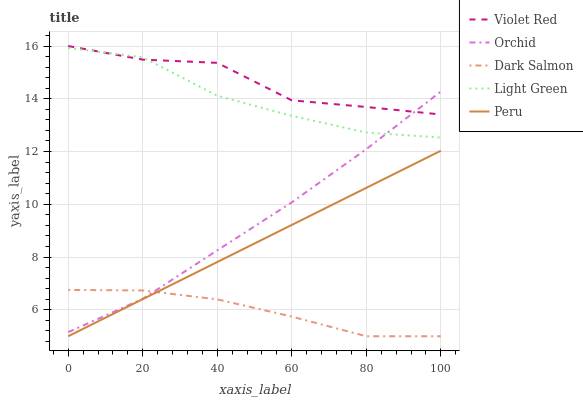Does Dark Salmon have the minimum area under the curve?
Answer yes or no. Yes. Does Violet Red have the maximum area under the curve?
Answer yes or no. Yes. Does Violet Red have the minimum area under the curve?
Answer yes or no. No. Does Dark Salmon have the maximum area under the curve?
Answer yes or no. No. Is Peru the smoothest?
Answer yes or no. Yes. Is Violet Red the roughest?
Answer yes or no. Yes. Is Dark Salmon the smoothest?
Answer yes or no. No. Is Dark Salmon the roughest?
Answer yes or no. No. Does Peru have the lowest value?
Answer yes or no. Yes. Does Violet Red have the lowest value?
Answer yes or no. No. Does Violet Red have the highest value?
Answer yes or no. Yes. Does Dark Salmon have the highest value?
Answer yes or no. No. Is Dark Salmon less than Violet Red?
Answer yes or no. Yes. Is Violet Red greater than Peru?
Answer yes or no. Yes. Does Light Green intersect Orchid?
Answer yes or no. Yes. Is Light Green less than Orchid?
Answer yes or no. No. Is Light Green greater than Orchid?
Answer yes or no. No. Does Dark Salmon intersect Violet Red?
Answer yes or no. No. 